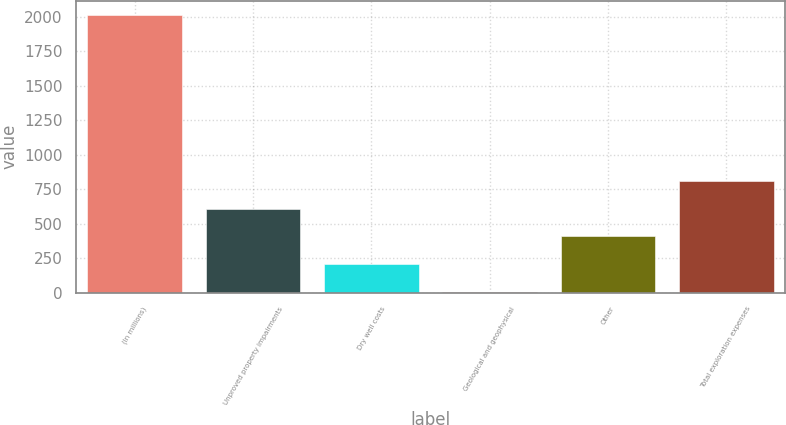Convert chart to OTSL. <chart><loc_0><loc_0><loc_500><loc_500><bar_chart><fcel>(In millions)<fcel>Unproved property impairments<fcel>Dry well costs<fcel>Geological and geophysical<fcel>Other<fcel>Total exploration expenses<nl><fcel>2016<fcel>608.3<fcel>206.1<fcel>5<fcel>407.2<fcel>809.4<nl></chart> 